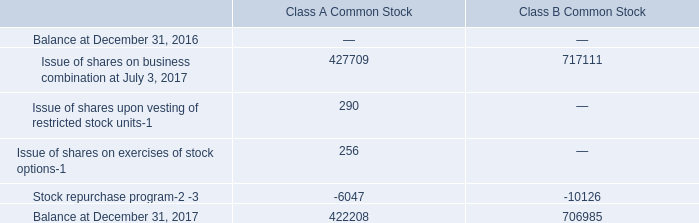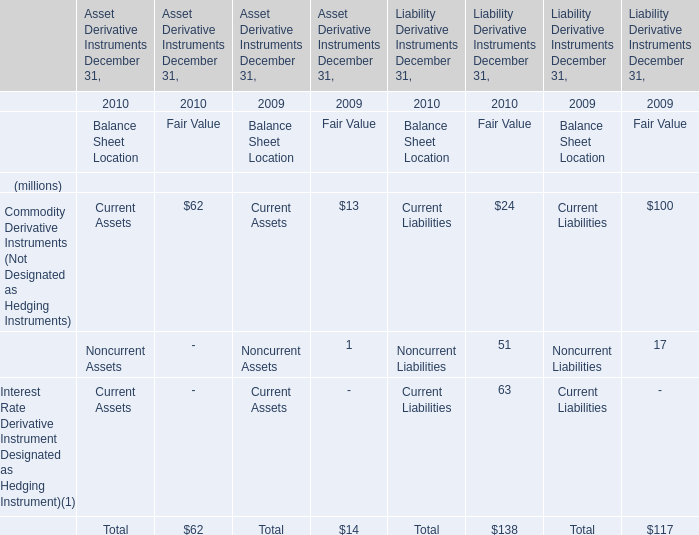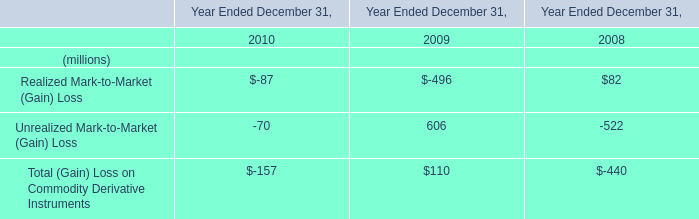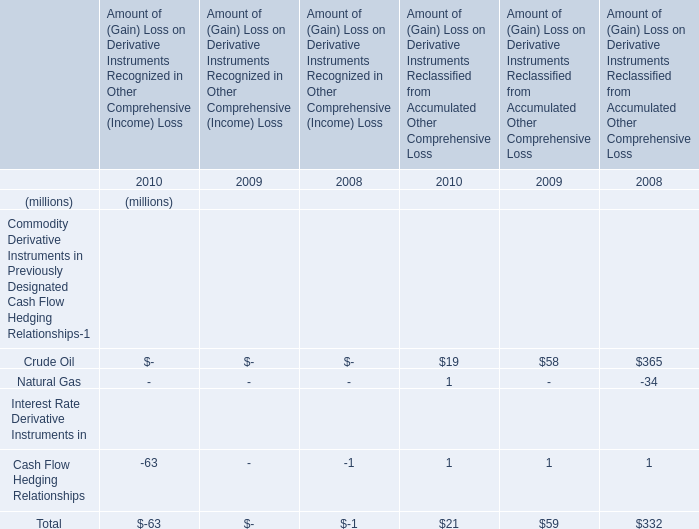what portion of the authorized shares of class a common stock is outstanding as of december 31 , 2017? 
Computations: (422 / (2 * 1000))
Answer: 0.211. 